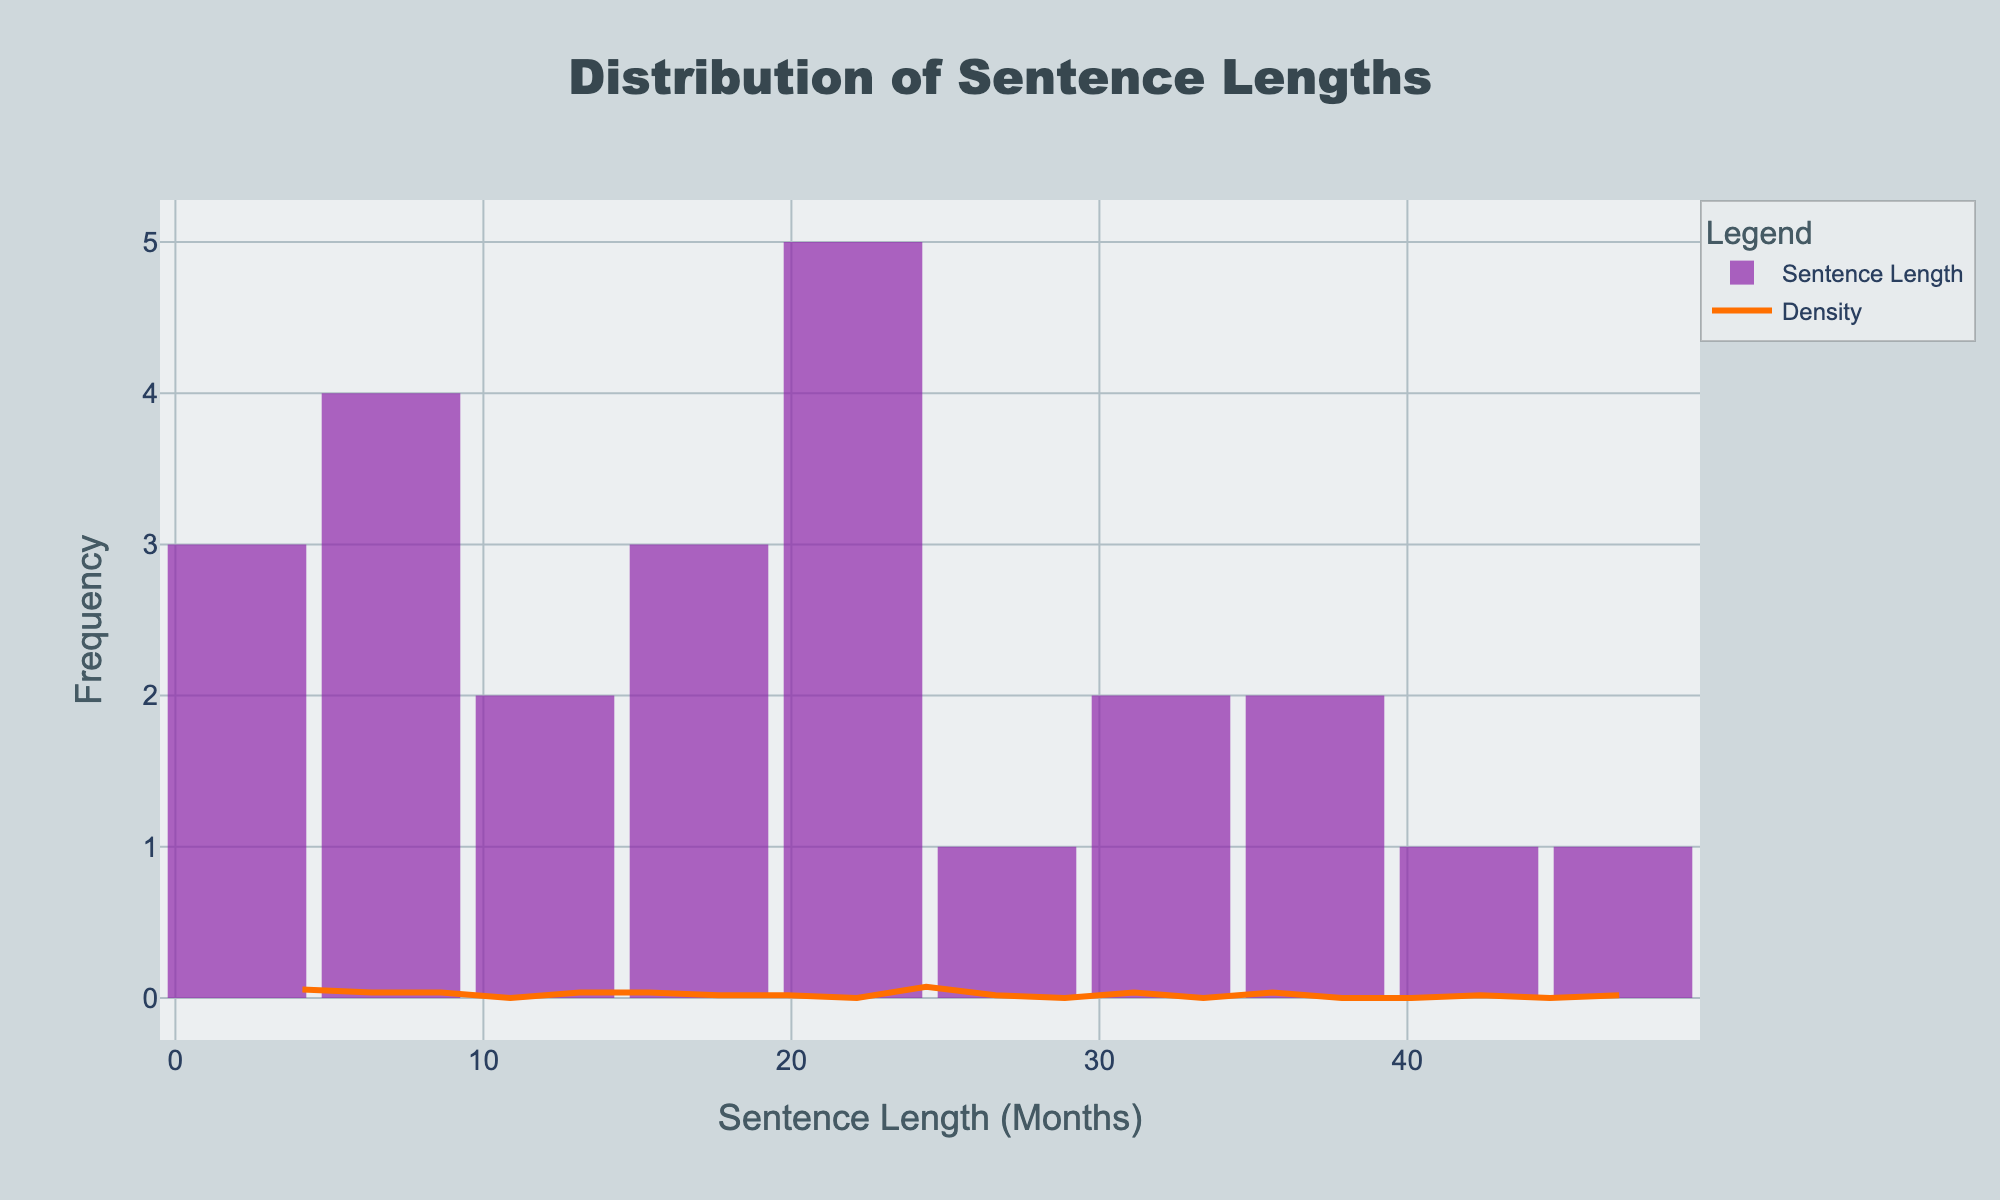What is the title of the figure? The title of the figure is usually displayed at the top of the chart. In this case, it is likely displayed in a prominent font.
Answer: Distribution of Sentence Lengths What are the x-axis and y-axis titles? The x-axis title is typically shown below the horizontal axis and the y-axis title next to the vertical axis. Both titles give context to the data presented.
Answer: Sentence Length (Months), Frequency How is the color of the KDE (density) curve different from the histogram bars? The color of the KDE curve is distinct from the histogram bars to differentiate the data presentation. The KDE curve is a line, while histogram bars are typically filled.
Answer: The KDE curve is orange, while the histogram bars are purple Which offense appears to result in the longest sentence lengths? By reviewing the distribution of sentence lengths across different offenses, a noticeable higher maximum value can indicate the longest sentence set for a particular offense.
Answer: Assault What race corresponds to the maximum sentence length in the dataset? Identifying the race associated with the longest sentence requires finding the sentence with the greatest length and associating it with the respective race.
Answer: Black What's the average sentence length for DUI offenses? Calculate the mean sentence length for DUI by summing the sentence lengths for DUI and dividing by the number of instances.
Answer: The average is (3 + 6 + 4 + 3) / 4 = 4 months Compare the sentence lengths between Drug Possession offenses and Fraud offenses. Which one is generally longer? Analyze the distribution of sentence lengths for both offenses. Typically, compare their medians or means to determine which tends to be longer.
Answer: Generally, Fraud offenses have longer sentences What is the range of sentence lengths for Burglary offenses? Compute the range by finding the difference between the maximum and minimum sentence lengths for Burglary.
Answer: The range is 24 - 16 = 8 months How does the frequency of short sentences (0-10 months) compare to long sentences (30-50 months)? By observing the histogram bins, count the frequency of sentences that fall into the short and long ranges and compare these counts.
Answer: Short sentences are more frequent than long sentences What can you infer about racial disparities in sentencing based on this figure? By analyzing the differences in sentence lengths across races for various offenses, you can infer which racial groups might receive longer or shorter sentences.
Answer: Black individuals generally receive longer sentences across several offenses 